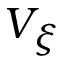<formula> <loc_0><loc_0><loc_500><loc_500>V _ { \xi }</formula> 